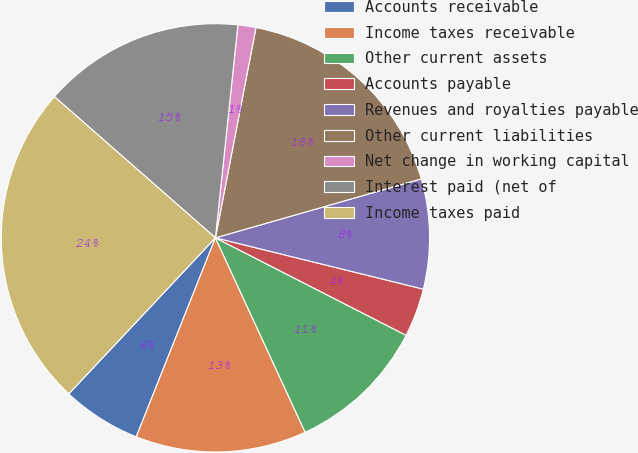<chart> <loc_0><loc_0><loc_500><loc_500><pie_chart><fcel>Accounts receivable<fcel>Income taxes receivable<fcel>Other current assets<fcel>Accounts payable<fcel>Revenues and royalties payable<fcel>Other current liabilities<fcel>Net change in working capital<fcel>Interest paid (net of<fcel>Income taxes paid<nl><fcel>5.98%<fcel>12.91%<fcel>10.6%<fcel>3.67%<fcel>8.29%<fcel>17.53%<fcel>1.36%<fcel>15.22%<fcel>24.45%<nl></chart> 